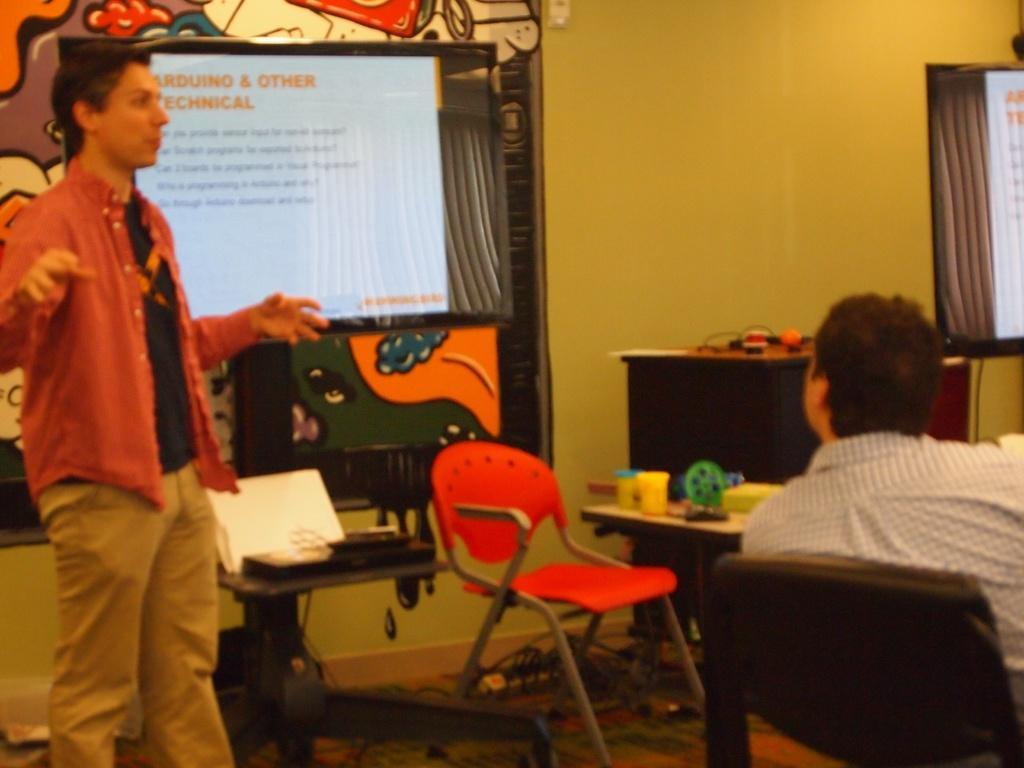How would you summarize this image in a sentence or two? A person is standing on the left and explaining. Right there is a person sitting on the chair. 